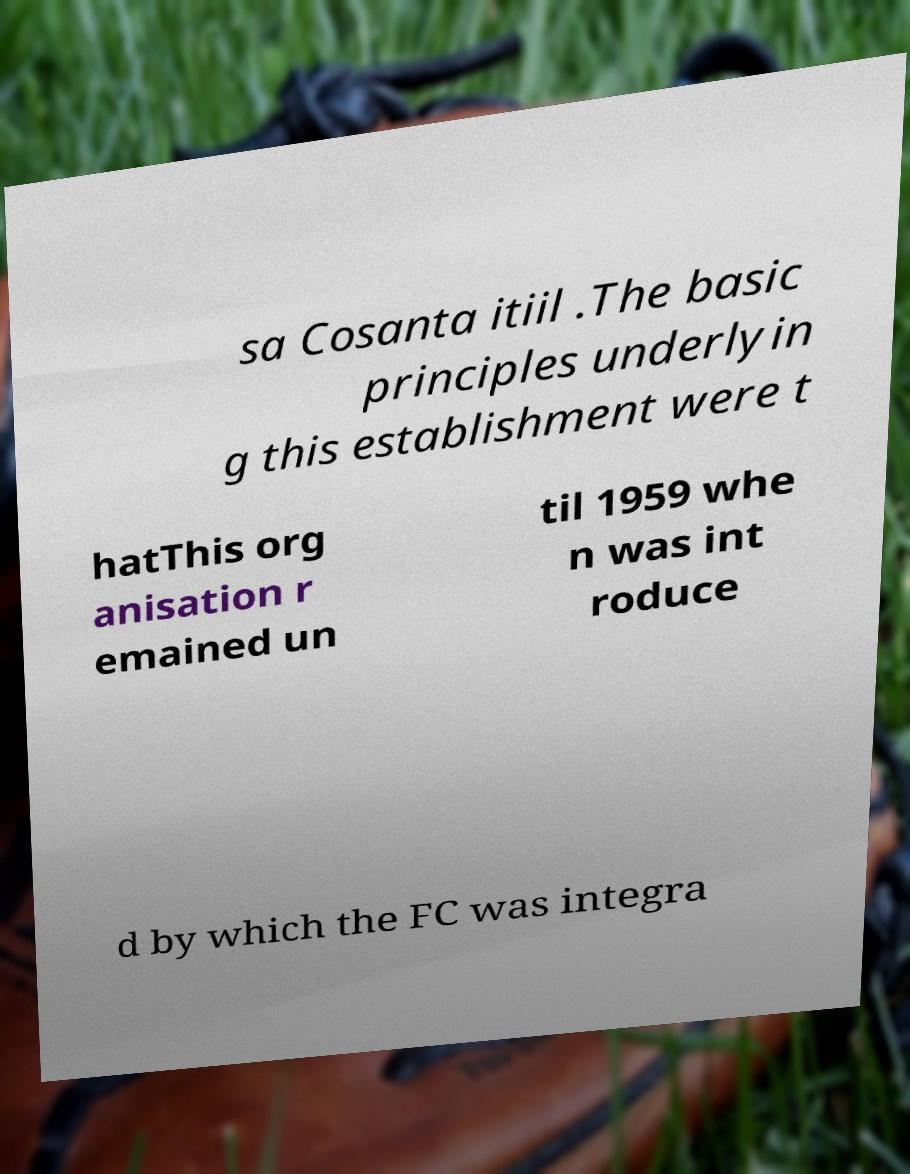Please read and relay the text visible in this image. What does it say? sa Cosanta itiil .The basic principles underlyin g this establishment were t hatThis org anisation r emained un til 1959 whe n was int roduce d by which the FC was integra 